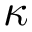Convert formula to latex. <formula><loc_0><loc_0><loc_500><loc_500>\kappa</formula> 